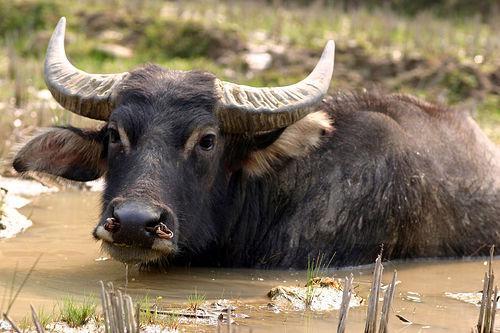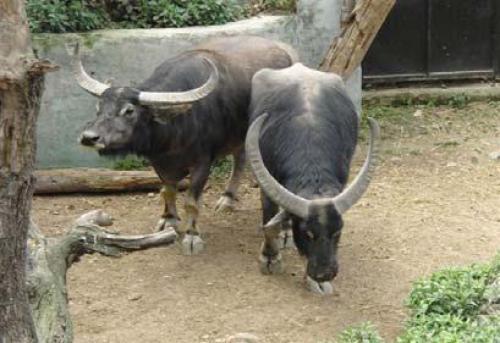The first image is the image on the left, the second image is the image on the right. Examine the images to the left and right. Is the description "There are at most 5 water buffalo." accurate? Answer yes or no. Yes. The first image is the image on the left, the second image is the image on the right. Given the left and right images, does the statement "There are fewer than 5 water buffalos" hold true? Answer yes or no. Yes. 